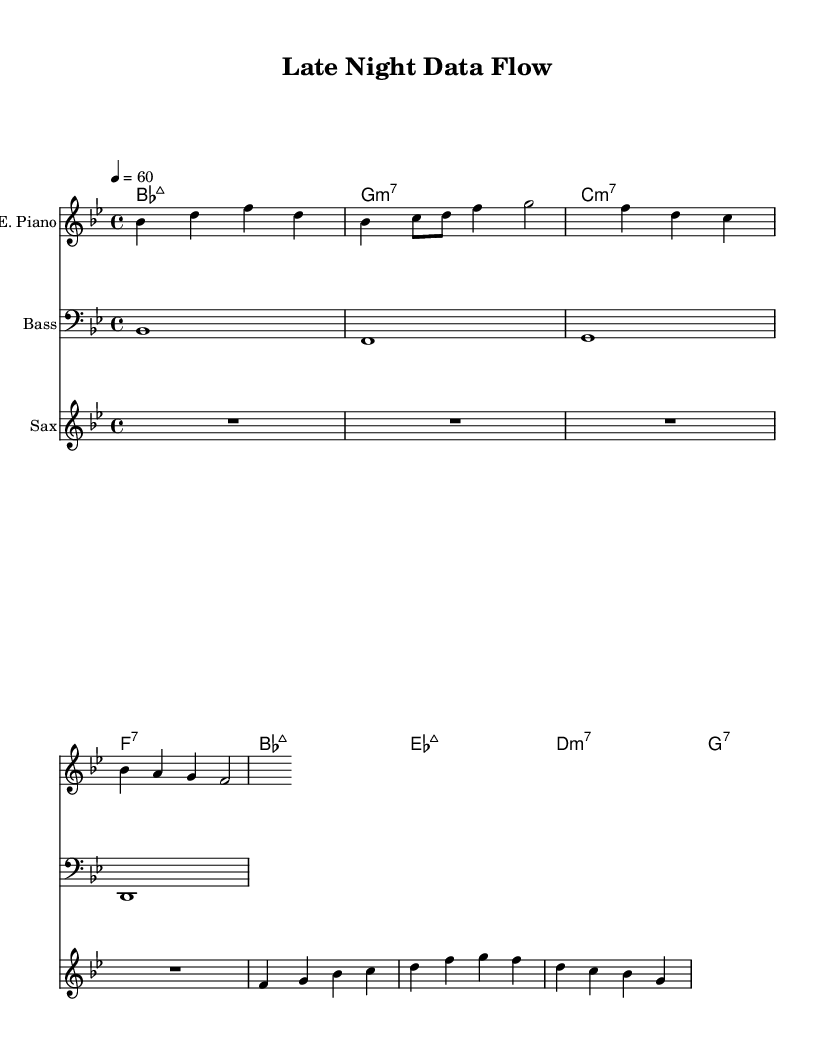What is the key signature of this music? The key signature is B flat major, which has two flats (B flat and E flat). This is indicated at the beginning of the staff.
Answer: B flat major What is the time signature of this music? The time signature is 4/4, denoting four beats per measure. This is seen at the beginning of the sheet music after the key signature.
Answer: 4/4 What is the tempo marking for this piece? The tempo marking is 60 beats per minute, indicated at the beginning of the score, suggesting a slow pace suitable for a mellow groove.
Answer: 60 How many instruments are featured in this sheet music? There are three instruments presented in the score: Electric Piano, Bass, and Saxophone. This is evident from the three separate staves created for each instrument.
Answer: Three What kind of chord is used in the first measure of the chord progression? The chord in the first measure is a B flat major seventh chord, indicated by "maj7". It requires combining the notes B flat, D, F, and A.
Answer: B flat major seventh Which instrument is playing the chord progression? The chord progression is played by the chord names staff, which is specifically meant for chords, rather than any instrument. This is evident as it does not have a clef or staff lines used for instrumental parts.
Answer: Chord names staff What is the last note played by the saxophone in the score? The last note played by the saxophone is a G. This can be determined by looking closely at the final measure for the saxophone part.
Answer: G 